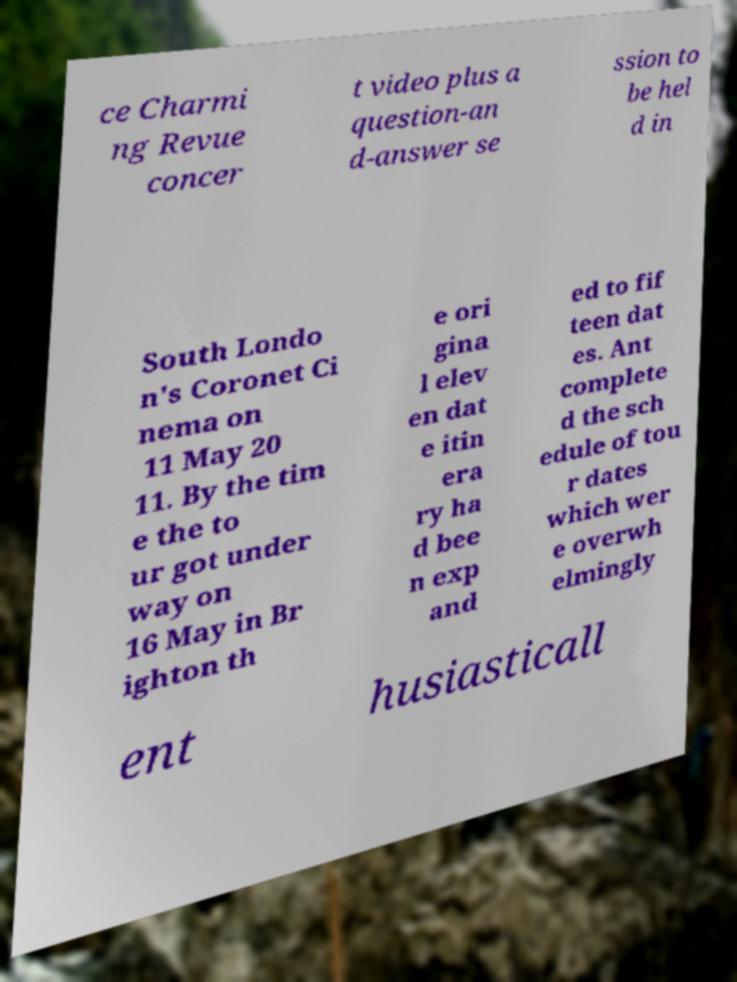For documentation purposes, I need the text within this image transcribed. Could you provide that? ce Charmi ng Revue concer t video plus a question-an d-answer se ssion to be hel d in South Londo n's Coronet Ci nema on 11 May 20 11. By the tim e the to ur got under way on 16 May in Br ighton th e ori gina l elev en dat e itin era ry ha d bee n exp and ed to fif teen dat es. Ant complete d the sch edule of tou r dates which wer e overwh elmingly ent husiasticall 